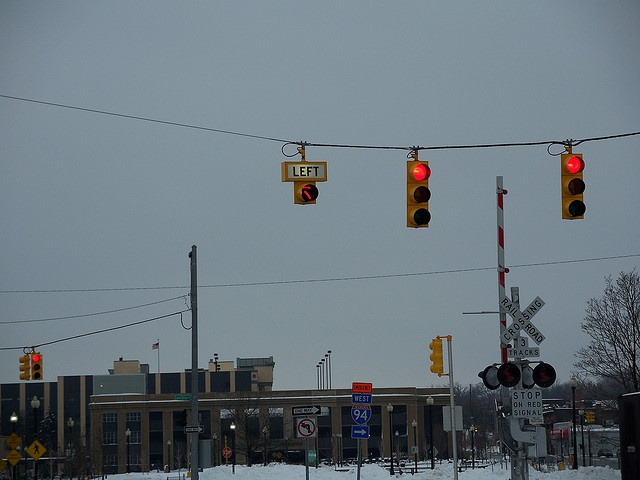Describe the objects in this image and their specific colors. I can see traffic light in gray, black, and darkgray tones, traffic light in gray, maroon, black, and red tones, traffic light in gray, black, maroon, and red tones, traffic light in gray, maroon, and black tones, and traffic light in gray and olive tones in this image. 